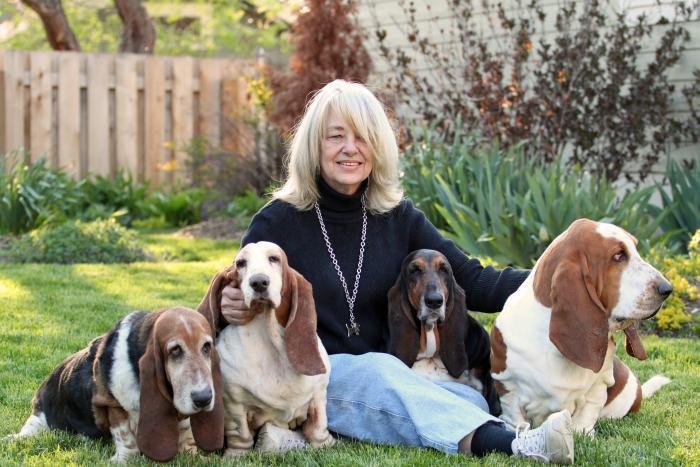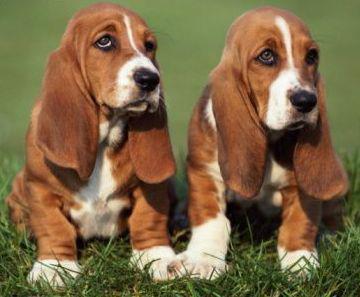The first image is the image on the left, the second image is the image on the right. Examine the images to the left and right. Is the description "All dogs are in the grass." accurate? Answer yes or no. Yes. The first image is the image on the left, the second image is the image on the right. For the images displayed, is the sentence "There is one image that includes a number of basset hounds that is now two." factually correct? Answer yes or no. Yes. The first image is the image on the left, the second image is the image on the right. Considering the images on both sides, is "One of the image shows only basset hounds, while the other shows a human with at least one basset hound." valid? Answer yes or no. Yes. The first image is the image on the left, the second image is the image on the right. Considering the images on both sides, is "The right image shows side-by-side basset hounds posed in the grass, and the left image shows one human posed in the grass with at least one basset hound." valid? Answer yes or no. Yes. 